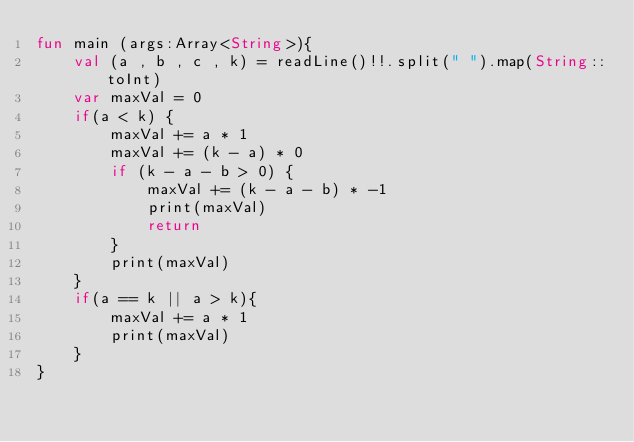<code> <loc_0><loc_0><loc_500><loc_500><_Kotlin_>fun main (args:Array<String>){
    val (a , b , c , k) = readLine()!!.split(" ").map(String::toInt)
    var maxVal = 0
    if(a < k) {
        maxVal += a * 1
        maxVal += (k - a) * 0
        if (k - a - b > 0) {
            maxVal += (k - a - b) * -1
            print(maxVal)
            return
        }
        print(maxVal)
    }
    if(a == k || a > k){
        maxVal += a * 1
        print(maxVal)
    }
}</code> 